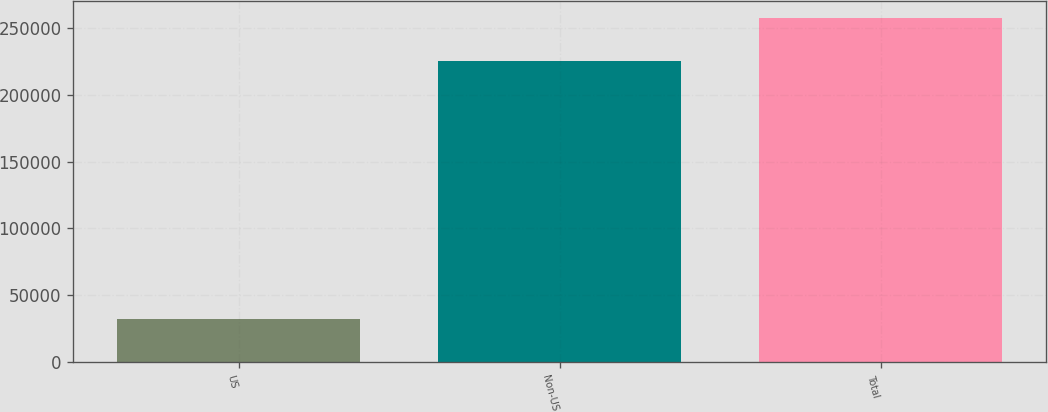Convert chart to OTSL. <chart><loc_0><loc_0><loc_500><loc_500><bar_chart><fcel>US<fcel>Non-US<fcel>Total<nl><fcel>32627<fcel>225056<fcel>257683<nl></chart> 